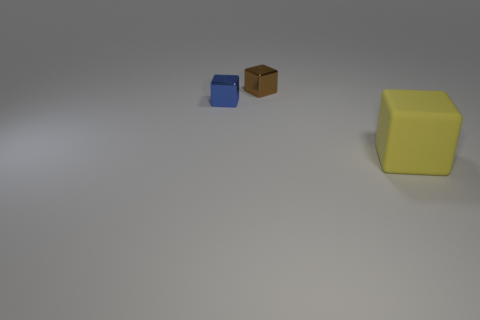Is there any other thing that has the same material as the large yellow block?
Provide a short and direct response. No. There is a small metal block behind the small blue cube to the left of the brown object; what is its color?
Make the answer very short. Brown. There is a object to the left of the metallic cube behind the block on the left side of the small brown thing; what is it made of?
Your answer should be compact. Metal. There is a cube behind the blue block; is it the same size as the large yellow matte block?
Your answer should be compact. No. What material is the cube that is right of the small brown metallic block?
Offer a terse response. Rubber. Are there more tiny cyan rubber cylinders than shiny objects?
Provide a short and direct response. No. What number of objects are cubes that are behind the large yellow thing or small cubes?
Your response must be concise. 2. There is a tiny shiny block to the left of the small brown block; how many big matte blocks are in front of it?
Ensure brevity in your answer.  1. How big is the metallic cube that is in front of the small metal object that is behind the shiny cube in front of the brown metal cube?
Your answer should be compact. Small. There is a tiny block that is left of the brown cube; is it the same color as the matte object?
Offer a very short reply. No. 